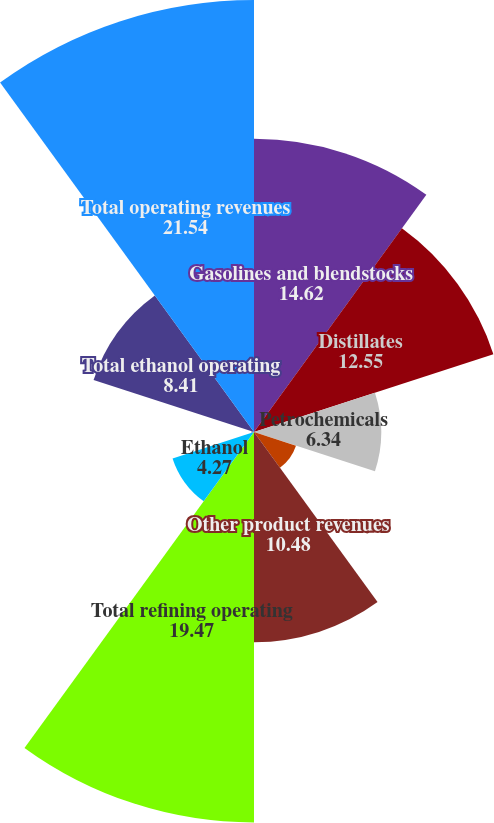<chart> <loc_0><loc_0><loc_500><loc_500><pie_chart><fcel>Gasolines and blendstocks<fcel>Distillates<fcel>Petrochemicals<fcel>Lubes and asphalts<fcel>Other product revenues<fcel>Total refining operating<fcel>Ethanol<fcel>Distillers grains<fcel>Total ethanol operating<fcel>Total operating revenues<nl><fcel>14.62%<fcel>12.55%<fcel>6.34%<fcel>2.2%<fcel>10.48%<fcel>19.47%<fcel>4.27%<fcel>0.13%<fcel>8.41%<fcel>21.54%<nl></chart> 